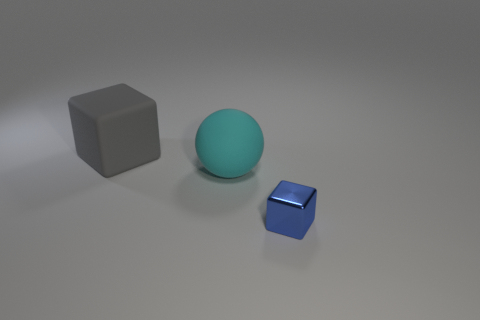Add 1 blue metallic blocks. How many objects exist? 4 Subtract all spheres. How many objects are left? 2 Subtract 0 yellow cubes. How many objects are left? 3 Subtract all tiny blue metallic things. Subtract all big matte spheres. How many objects are left? 1 Add 3 gray rubber cubes. How many gray rubber cubes are left? 4 Add 3 cyan matte spheres. How many cyan matte spheres exist? 4 